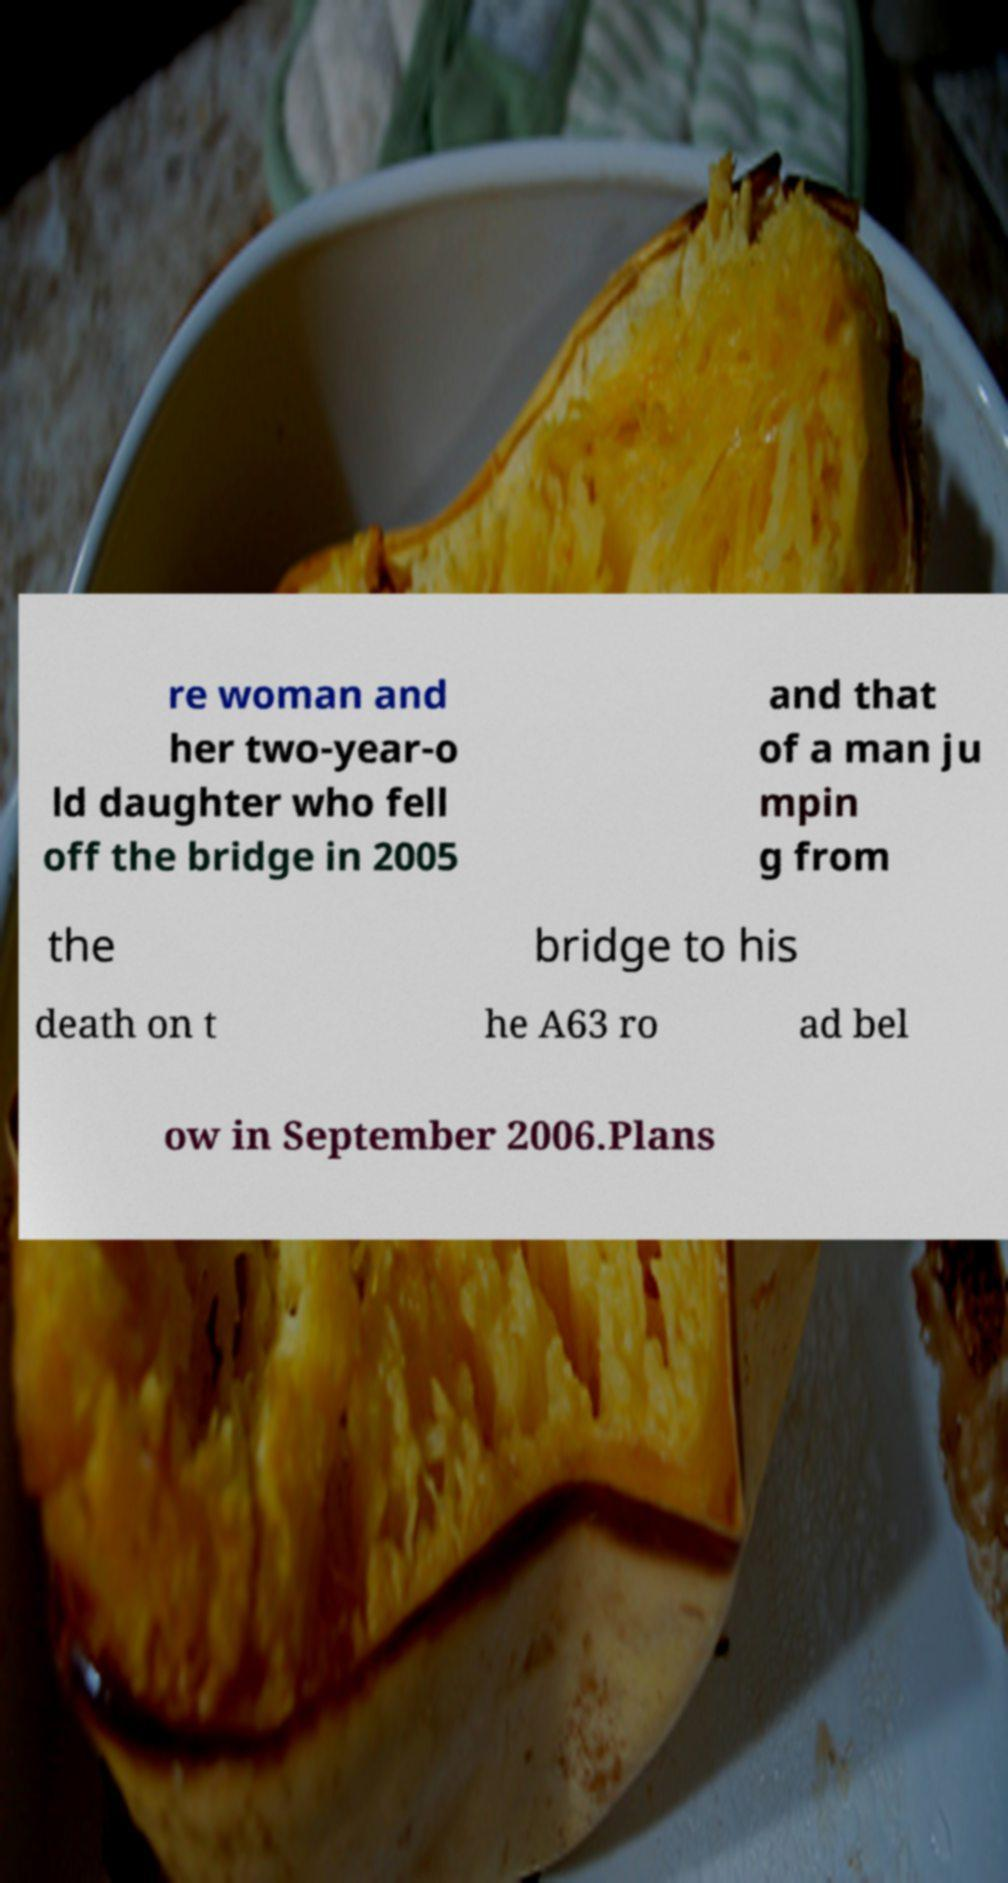Please identify and transcribe the text found in this image. re woman and her two-year-o ld daughter who fell off the bridge in 2005 and that of a man ju mpin g from the bridge to his death on t he A63 ro ad bel ow in September 2006.Plans 